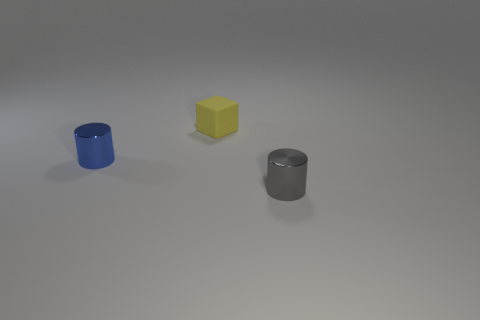The tiny matte block is what color?
Your response must be concise. Yellow. How many other things are the same size as the yellow matte object?
Your answer should be very brief. 2. What is the material of the small blue object that is the same shape as the tiny gray thing?
Your answer should be compact. Metal. There is a tiny cylinder in front of the cylinder that is to the left of the cylinder to the right of the blue cylinder; what is its material?
Offer a very short reply. Metal. What size is the object that is the same material as the gray cylinder?
Your answer should be compact. Small. Are there any other things that have the same color as the small rubber thing?
Your response must be concise. No. There is a shiny object that is behind the gray shiny cylinder; is its color the same as the object that is behind the blue metal thing?
Give a very brief answer. No. What is the color of the cylinder to the right of the tiny blue metallic cylinder?
Offer a very short reply. Gray. Do the gray metal thing that is in front of the matte thing and the tiny cube have the same size?
Provide a short and direct response. Yes. Is the number of large red rubber objects less than the number of metal things?
Offer a very short reply. Yes. 